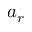Convert formula to latex. <formula><loc_0><loc_0><loc_500><loc_500>a _ { r }</formula> 